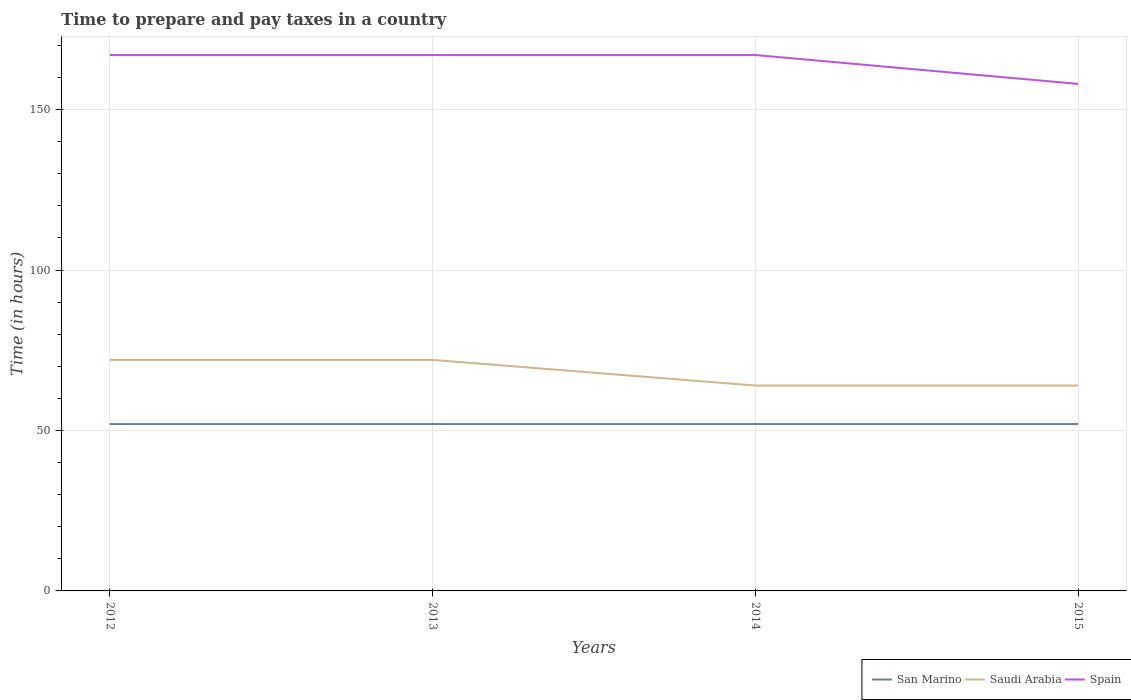What is the total number of hours required to prepare and pay taxes in Spain in the graph?
Your answer should be very brief. 9. What is the difference between the highest and the second highest number of hours required to prepare and pay taxes in Saudi Arabia?
Keep it short and to the point. 8. What is the difference between the highest and the lowest number of hours required to prepare and pay taxes in Saudi Arabia?
Offer a terse response. 2. How many years are there in the graph?
Your answer should be compact. 4. Are the values on the major ticks of Y-axis written in scientific E-notation?
Your response must be concise. No. Where does the legend appear in the graph?
Provide a succinct answer. Bottom right. How many legend labels are there?
Offer a terse response. 3. What is the title of the graph?
Provide a succinct answer. Time to prepare and pay taxes in a country. What is the label or title of the Y-axis?
Offer a terse response. Time (in hours). What is the Time (in hours) in San Marino in 2012?
Ensure brevity in your answer.  52. What is the Time (in hours) of Saudi Arabia in 2012?
Your response must be concise. 72. What is the Time (in hours) in Spain in 2012?
Ensure brevity in your answer.  167. What is the Time (in hours) of San Marino in 2013?
Your response must be concise. 52. What is the Time (in hours) in Saudi Arabia in 2013?
Ensure brevity in your answer.  72. What is the Time (in hours) in Spain in 2013?
Make the answer very short. 167. What is the Time (in hours) of San Marino in 2014?
Give a very brief answer. 52. What is the Time (in hours) in Saudi Arabia in 2014?
Your response must be concise. 64. What is the Time (in hours) in Spain in 2014?
Your response must be concise. 167. What is the Time (in hours) of Saudi Arabia in 2015?
Make the answer very short. 64. What is the Time (in hours) of Spain in 2015?
Provide a short and direct response. 158. Across all years, what is the maximum Time (in hours) of Saudi Arabia?
Your answer should be compact. 72. Across all years, what is the maximum Time (in hours) in Spain?
Your answer should be very brief. 167. Across all years, what is the minimum Time (in hours) in San Marino?
Offer a terse response. 52. Across all years, what is the minimum Time (in hours) of Spain?
Offer a terse response. 158. What is the total Time (in hours) in San Marino in the graph?
Offer a very short reply. 208. What is the total Time (in hours) of Saudi Arabia in the graph?
Make the answer very short. 272. What is the total Time (in hours) of Spain in the graph?
Your answer should be very brief. 659. What is the difference between the Time (in hours) of San Marino in 2012 and that in 2013?
Your answer should be very brief. 0. What is the difference between the Time (in hours) of Saudi Arabia in 2012 and that in 2013?
Make the answer very short. 0. What is the difference between the Time (in hours) in San Marino in 2012 and that in 2014?
Make the answer very short. 0. What is the difference between the Time (in hours) in Saudi Arabia in 2012 and that in 2014?
Provide a succinct answer. 8. What is the difference between the Time (in hours) of Saudi Arabia in 2012 and that in 2015?
Provide a succinct answer. 8. What is the difference between the Time (in hours) of Spain in 2012 and that in 2015?
Provide a short and direct response. 9. What is the difference between the Time (in hours) of Spain in 2013 and that in 2014?
Keep it short and to the point. 0. What is the difference between the Time (in hours) in Spain in 2013 and that in 2015?
Make the answer very short. 9. What is the difference between the Time (in hours) in Saudi Arabia in 2014 and that in 2015?
Make the answer very short. 0. What is the difference between the Time (in hours) in Spain in 2014 and that in 2015?
Your answer should be compact. 9. What is the difference between the Time (in hours) in San Marino in 2012 and the Time (in hours) in Saudi Arabia in 2013?
Offer a terse response. -20. What is the difference between the Time (in hours) of San Marino in 2012 and the Time (in hours) of Spain in 2013?
Make the answer very short. -115. What is the difference between the Time (in hours) in Saudi Arabia in 2012 and the Time (in hours) in Spain in 2013?
Ensure brevity in your answer.  -95. What is the difference between the Time (in hours) of San Marino in 2012 and the Time (in hours) of Saudi Arabia in 2014?
Your answer should be very brief. -12. What is the difference between the Time (in hours) in San Marino in 2012 and the Time (in hours) in Spain in 2014?
Provide a short and direct response. -115. What is the difference between the Time (in hours) of Saudi Arabia in 2012 and the Time (in hours) of Spain in 2014?
Provide a succinct answer. -95. What is the difference between the Time (in hours) in San Marino in 2012 and the Time (in hours) in Saudi Arabia in 2015?
Provide a short and direct response. -12. What is the difference between the Time (in hours) of San Marino in 2012 and the Time (in hours) of Spain in 2015?
Your response must be concise. -106. What is the difference between the Time (in hours) of Saudi Arabia in 2012 and the Time (in hours) of Spain in 2015?
Keep it short and to the point. -86. What is the difference between the Time (in hours) of San Marino in 2013 and the Time (in hours) of Spain in 2014?
Offer a very short reply. -115. What is the difference between the Time (in hours) in Saudi Arabia in 2013 and the Time (in hours) in Spain in 2014?
Your response must be concise. -95. What is the difference between the Time (in hours) of San Marino in 2013 and the Time (in hours) of Saudi Arabia in 2015?
Your answer should be compact. -12. What is the difference between the Time (in hours) in San Marino in 2013 and the Time (in hours) in Spain in 2015?
Your response must be concise. -106. What is the difference between the Time (in hours) in Saudi Arabia in 2013 and the Time (in hours) in Spain in 2015?
Make the answer very short. -86. What is the difference between the Time (in hours) in San Marino in 2014 and the Time (in hours) in Spain in 2015?
Provide a short and direct response. -106. What is the difference between the Time (in hours) in Saudi Arabia in 2014 and the Time (in hours) in Spain in 2015?
Ensure brevity in your answer.  -94. What is the average Time (in hours) of Spain per year?
Your response must be concise. 164.75. In the year 2012, what is the difference between the Time (in hours) of San Marino and Time (in hours) of Saudi Arabia?
Provide a succinct answer. -20. In the year 2012, what is the difference between the Time (in hours) of San Marino and Time (in hours) of Spain?
Provide a succinct answer. -115. In the year 2012, what is the difference between the Time (in hours) in Saudi Arabia and Time (in hours) in Spain?
Your answer should be very brief. -95. In the year 2013, what is the difference between the Time (in hours) in San Marino and Time (in hours) in Spain?
Provide a short and direct response. -115. In the year 2013, what is the difference between the Time (in hours) of Saudi Arabia and Time (in hours) of Spain?
Provide a short and direct response. -95. In the year 2014, what is the difference between the Time (in hours) of San Marino and Time (in hours) of Saudi Arabia?
Keep it short and to the point. -12. In the year 2014, what is the difference between the Time (in hours) of San Marino and Time (in hours) of Spain?
Your answer should be very brief. -115. In the year 2014, what is the difference between the Time (in hours) of Saudi Arabia and Time (in hours) of Spain?
Your answer should be compact. -103. In the year 2015, what is the difference between the Time (in hours) in San Marino and Time (in hours) in Spain?
Make the answer very short. -106. In the year 2015, what is the difference between the Time (in hours) in Saudi Arabia and Time (in hours) in Spain?
Your answer should be compact. -94. What is the ratio of the Time (in hours) in San Marino in 2012 to that in 2013?
Offer a very short reply. 1. What is the ratio of the Time (in hours) of Spain in 2012 to that in 2015?
Your answer should be compact. 1.06. What is the ratio of the Time (in hours) of San Marino in 2013 to that in 2014?
Provide a short and direct response. 1. What is the ratio of the Time (in hours) of Saudi Arabia in 2013 to that in 2014?
Your answer should be very brief. 1.12. What is the ratio of the Time (in hours) of Spain in 2013 to that in 2014?
Your response must be concise. 1. What is the ratio of the Time (in hours) in Spain in 2013 to that in 2015?
Your answer should be compact. 1.06. What is the ratio of the Time (in hours) of Saudi Arabia in 2014 to that in 2015?
Provide a succinct answer. 1. What is the ratio of the Time (in hours) in Spain in 2014 to that in 2015?
Your answer should be compact. 1.06. What is the difference between the highest and the second highest Time (in hours) in San Marino?
Provide a succinct answer. 0. What is the difference between the highest and the second highest Time (in hours) of Saudi Arabia?
Your answer should be compact. 0. What is the difference between the highest and the second highest Time (in hours) in Spain?
Offer a terse response. 0. What is the difference between the highest and the lowest Time (in hours) of San Marino?
Make the answer very short. 0. What is the difference between the highest and the lowest Time (in hours) of Saudi Arabia?
Keep it short and to the point. 8. What is the difference between the highest and the lowest Time (in hours) in Spain?
Give a very brief answer. 9. 